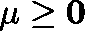<formula> <loc_0><loc_0><loc_500><loc_500>\mu \geq 0</formula> 